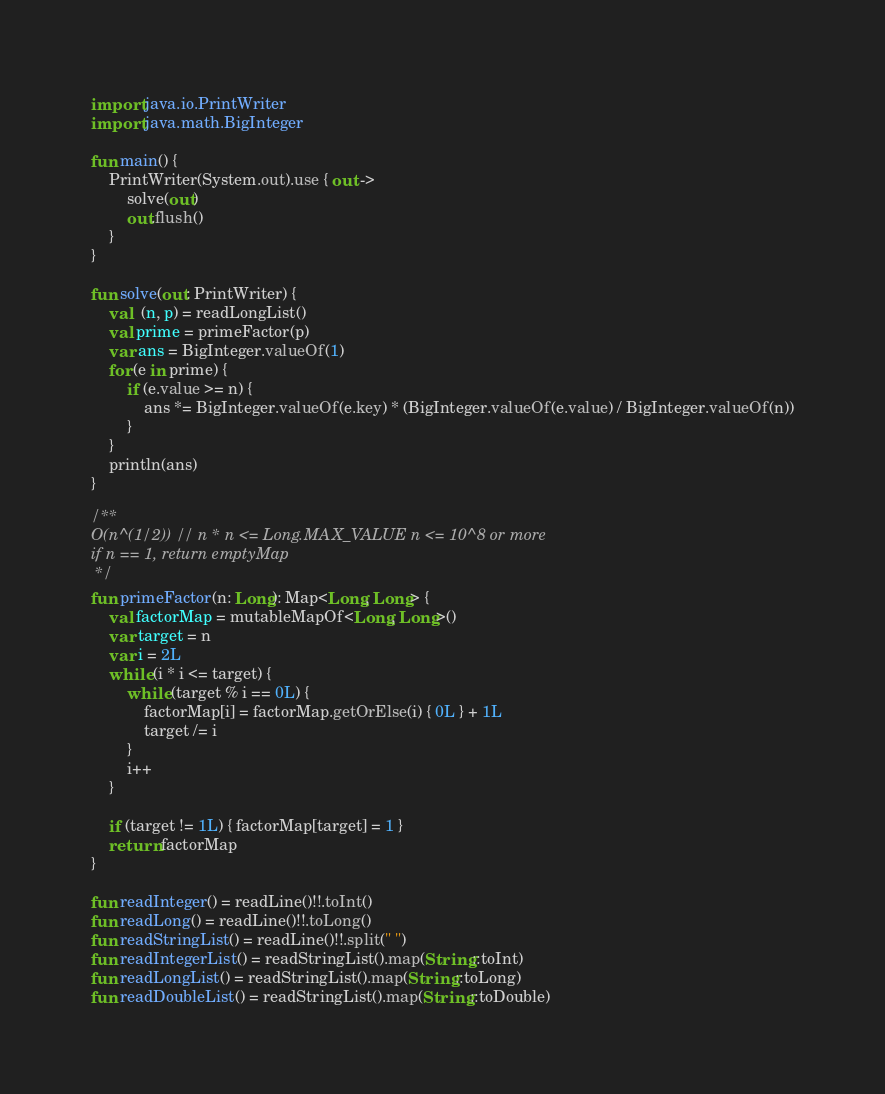<code> <loc_0><loc_0><loc_500><loc_500><_Kotlin_>import java.io.PrintWriter
import java.math.BigInteger

fun main() {
    PrintWriter(System.out).use { out ->
        solve(out)
        out.flush()
    }
}

fun solve(out: PrintWriter) {
    val  (n, p) = readLongList()
    val prime = primeFactor(p)
    var ans = BigInteger.valueOf(1)
    for (e in prime) {
        if (e.value >= n) {
            ans *= BigInteger.valueOf(e.key) * (BigInteger.valueOf(e.value) / BigInteger.valueOf(n))
        }
    }
    println(ans)
}

/**
O(n^(1/2)) // n * n <= Long.MAX_VALUE n <= 10^8 or more
if n == 1, return emptyMap
 */
fun primeFactor(n: Long): Map<Long, Long> {
    val factorMap = mutableMapOf<Long, Long>()
    var target = n
    var i = 2L
    while (i * i <= target) {
        while (target % i == 0L) {
            factorMap[i] = factorMap.getOrElse(i) { 0L } + 1L
            target /= i
        }
        i++
    }

    if (target != 1L) { factorMap[target] = 1 }
    return factorMap
}

fun readInteger() = readLine()!!.toInt()
fun readLong() = readLine()!!.toLong()
fun readStringList() = readLine()!!.split(" ")
fun readIntegerList() = readStringList().map(String::toInt)
fun readLongList() = readStringList().map(String::toLong)
fun readDoubleList() = readStringList().map(String::toDouble)
</code> 